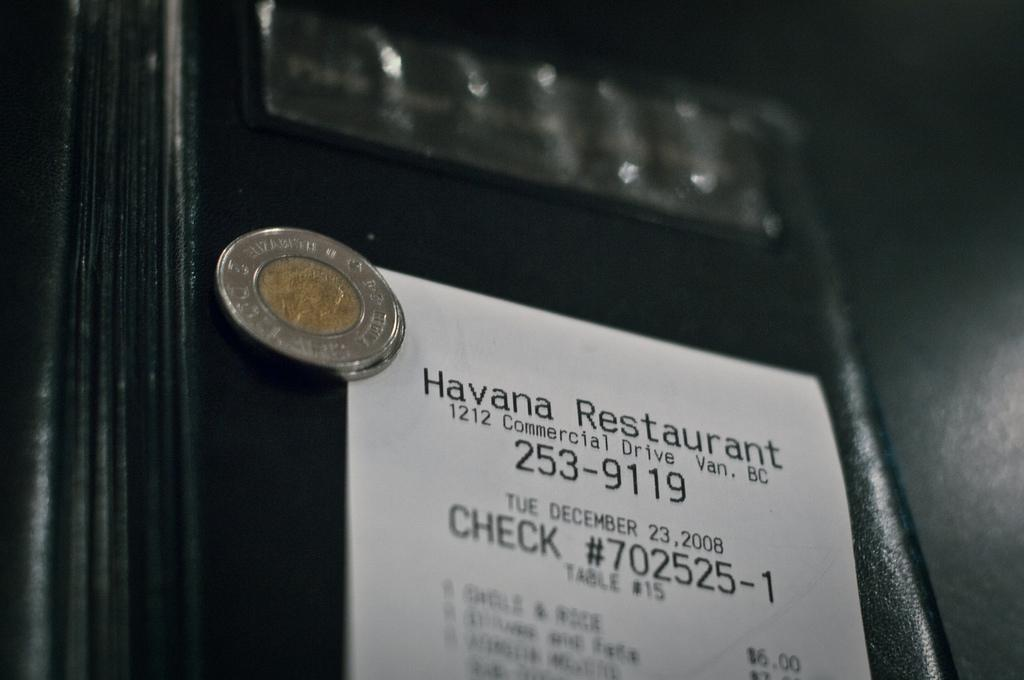<image>
Present a compact description of the photo's key features. a Havana restaurant receipt on December 23, 2008 